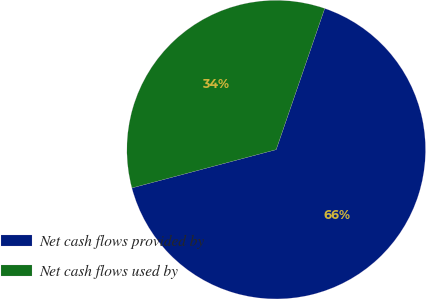<chart> <loc_0><loc_0><loc_500><loc_500><pie_chart><fcel>Net cash flows provided by<fcel>Net cash flows used by<nl><fcel>65.6%<fcel>34.4%<nl></chart> 